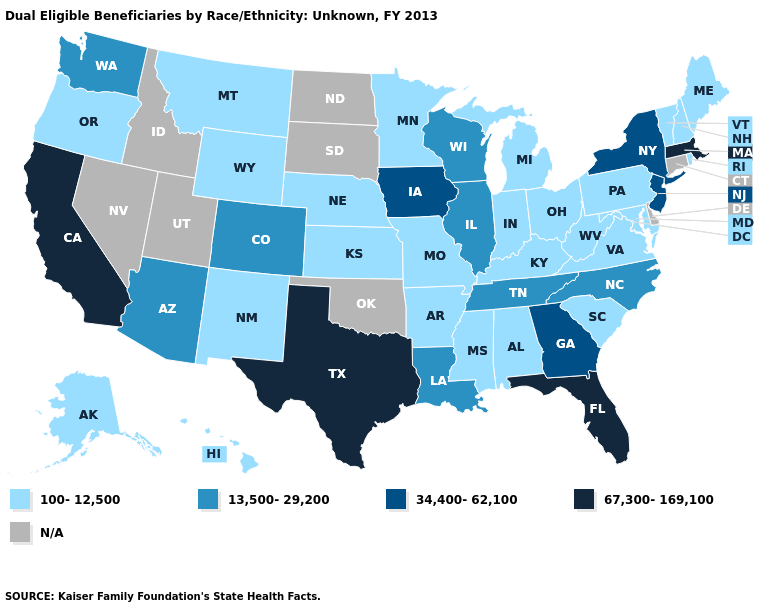Does Florida have the highest value in the USA?
Give a very brief answer. Yes. Which states hav the highest value in the South?
Keep it brief. Florida, Texas. Which states have the highest value in the USA?
Short answer required. California, Florida, Massachusetts, Texas. Is the legend a continuous bar?
Be succinct. No. Among the states that border Georgia , which have the lowest value?
Be succinct. Alabama, South Carolina. Name the states that have a value in the range 67,300-169,100?
Write a very short answer. California, Florida, Massachusetts, Texas. What is the lowest value in the USA?
Give a very brief answer. 100-12,500. What is the highest value in the MidWest ?
Concise answer only. 34,400-62,100. What is the highest value in states that border Indiana?
Keep it brief. 13,500-29,200. What is the value of California?
Keep it brief. 67,300-169,100. What is the value of Oklahoma?
Write a very short answer. N/A. Name the states that have a value in the range 100-12,500?
Short answer required. Alabama, Alaska, Arkansas, Hawaii, Indiana, Kansas, Kentucky, Maine, Maryland, Michigan, Minnesota, Mississippi, Missouri, Montana, Nebraska, New Hampshire, New Mexico, Ohio, Oregon, Pennsylvania, Rhode Island, South Carolina, Vermont, Virginia, West Virginia, Wyoming. How many symbols are there in the legend?
Concise answer only. 5. Name the states that have a value in the range 13,500-29,200?
Quick response, please. Arizona, Colorado, Illinois, Louisiana, North Carolina, Tennessee, Washington, Wisconsin. 